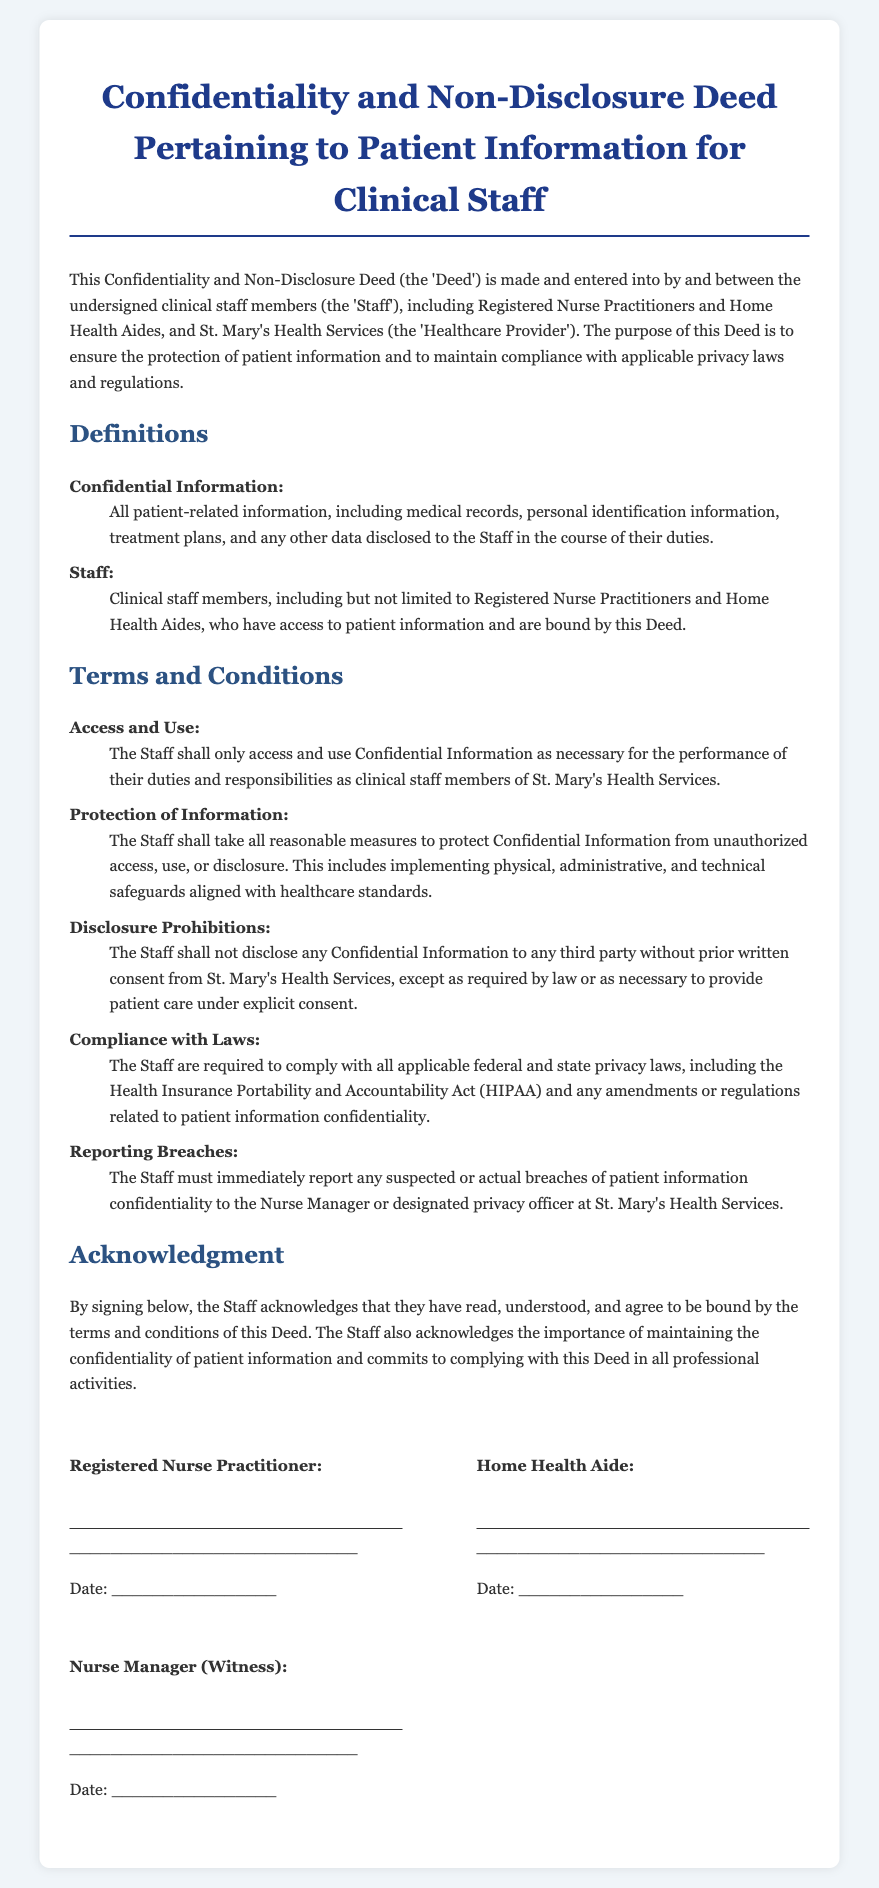What is the title of the document? The title is presented at the top of the document, highlighting the main subject.
Answer: Confidentiality and Non-Disclosure Deed Pertaining to Patient Information for Clinical Staff Who are the parties involved in this Deed? The parties involved are identified early in the document, specifying who is bound by the agreement.
Answer: Staff and St. Mary's Health Services What must the Staff do with Confidential Information? The document specifies actions that Staff must take regarding the Confidential Information, which can be found in the terms section.
Answer: Protect it Which privacy law must the Staff comply with? The document mentions specific laws that govern confidentiality that the Staff must adhere to.
Answer: HIPAA What must Staff do if they suspect a breach? The requirement for reporting breaches is outlined in the terms section of the document.
Answer: Report immediately Who are the signatories of the document? The signatories are listed at the bottom, indicating who is confirming the agreement.
Answer: Registered Nurse Practitioner, Home Health Aide, Nurse Manager (Witness) What is defined as Confidential Information in the document? The definitions section provides clarity on what constitutes Confidential Information.
Answer: All patient-related information How many days do Staff have to report a breach? The document states the expectation for immediate reporting without a specified time frame for delay.
Answer: Immediately 